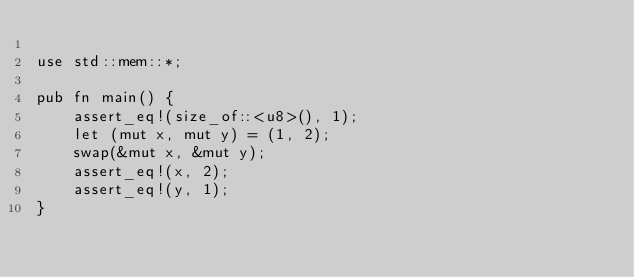<code> <loc_0><loc_0><loc_500><loc_500><_Rust_>
use std::mem::*;

pub fn main() {
    assert_eq!(size_of::<u8>(), 1);
    let (mut x, mut y) = (1, 2);
    swap(&mut x, &mut y);
    assert_eq!(x, 2);
    assert_eq!(y, 1);
}
</code> 